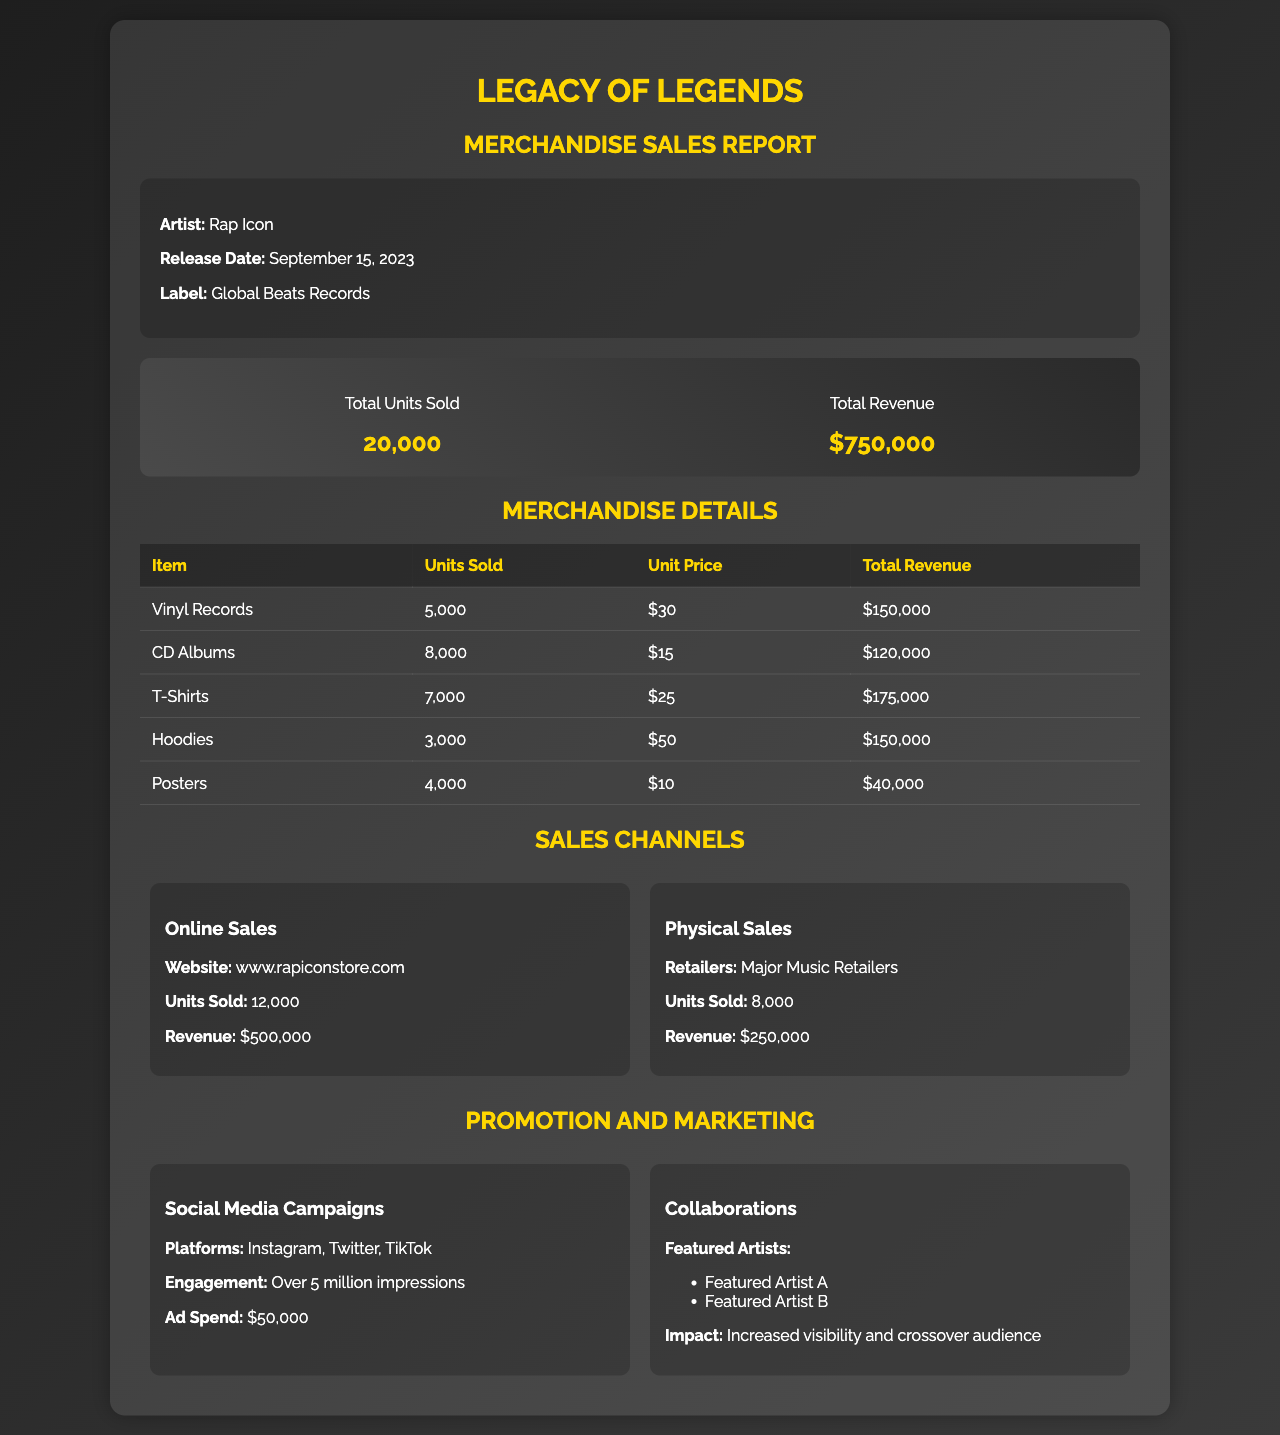What is the album title? The album title is mentioned prominently at the beginning of the document.
Answer: Legacy of Legends How many units of T-Shirts were sold? The document lists the units sold for each merchandise item in a table, specifically for T-Shirts.
Answer: 7,000 What is the total revenue generated from the album merchandise? The total revenue is summarized in the report as the overall revenue figure combining all merchandise sales.
Answer: $750,000 Which item generated the highest revenue? By examining the total revenue for each merchandise item in the table, one can identify the item contributing the most.
Answer: T-Shirts What is the engagement from social media campaigns? The document includes a section that details the impact and reach of marketing strategies, specifically social media engagements.
Answer: Over 5 million impressions How many units were sold through online sales? The document specifies the breakdown of units sold by sales channel, particularly for online sales.
Answer: 12,000 What is the label of the album? The label is mentioned in the album information section of the document.
Answer: Global Beats Records How many units of Vinyl Records were sold? The document contains specific sales data for each merchandise item and includes Vinyl Records sales.
Answer: 5,000 Who are the featured artists in the collaborations? The document lists featured artists under the promotion section, indicating collaboration details.
Answer: Featured Artist A, Featured Artist B 